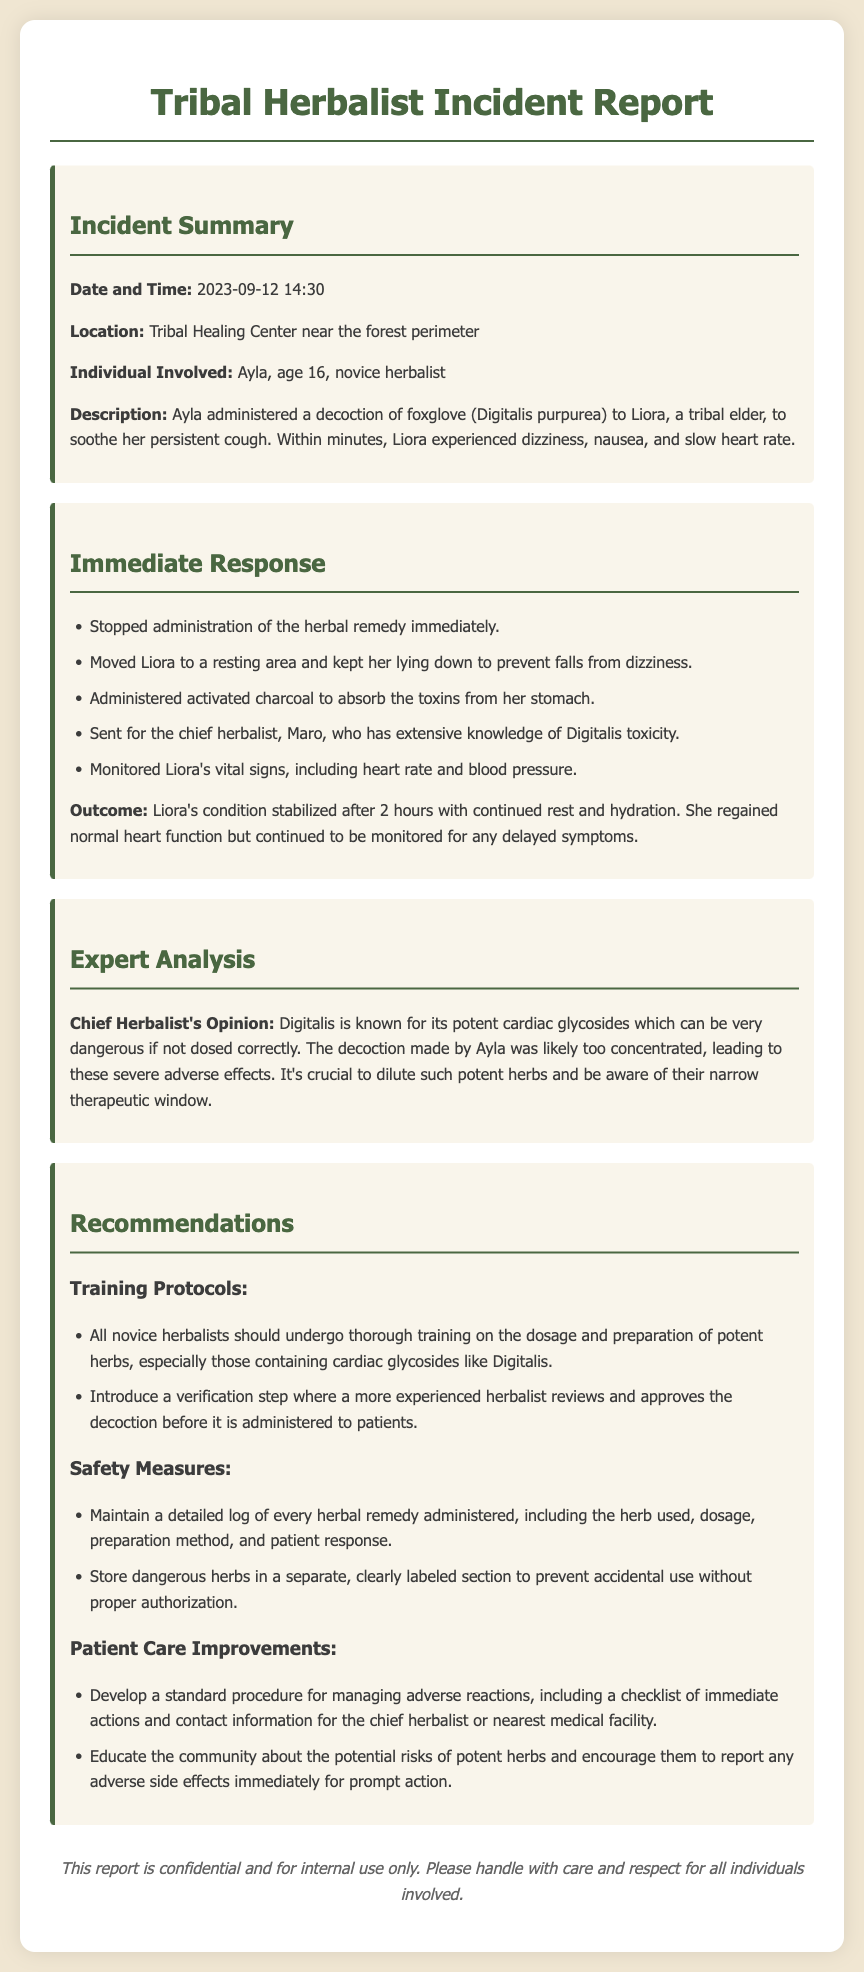What was the date of the incident? The date of the incident is mentioned in the report.
Answer: 2023-09-12 Who was the individual involved in the incident? The report states the name and age of the individual involved.
Answer: Ayla, age 16 What remedy was administered to Liora? The document specifies the herbal remedy used in the incident.
Answer: Decoction of foxglove What symptoms did Liora experience? The document lists the adverse reactions observed in Liora.
Answer: Dizziness, nausea, slow heart rate What was done immediately after the adverse reaction? The report provides a list of immediate responses taken after the incident.
Answer: Stopped administration of the herbal remedy Who is the chief herbalist mentioned in the report? The document identifies the chief herbalist involved in the response to the incident.
Answer: Maro What is an important safety measure recommended in the report? The report outlines safety measures to prevent future incidents.
Answer: Maintain a detailed log of every herbal remedy administered What was the outcome for Liora after the treatment? The document summarizes the outcome of Liora's condition post-treatment.
Answer: Condition stabilized after 2 hours What type of herb is Digitalis classified as? The report contains a description of the herb used and its properties.
Answer: Cardiac glycosides What specific training protocol is recommended for novice herbalists? The document details the training necessary for novice herbalists regarding potent herbs.
Answer: Thorough training on dosage and preparation of potent herbs 